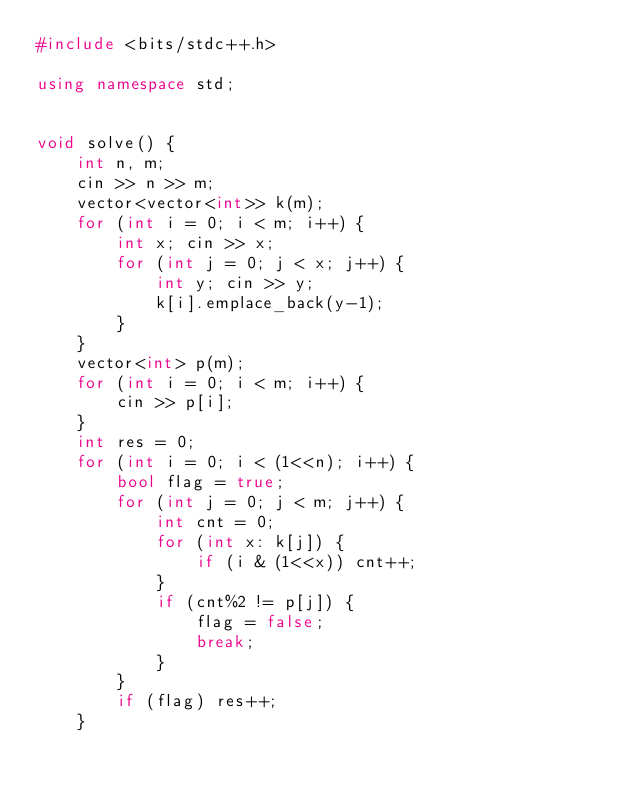<code> <loc_0><loc_0><loc_500><loc_500><_C++_>#include <bits/stdc++.h>

using namespace std;


void solve() {
    int n, m;
    cin >> n >> m;
    vector<vector<int>> k(m);
    for (int i = 0; i < m; i++) {
        int x; cin >> x;
        for (int j = 0; j < x; j++) {
            int y; cin >> y;
            k[i].emplace_back(y-1);
        }
    }
    vector<int> p(m);
    for (int i = 0; i < m; i++) {
        cin >> p[i];
    }
    int res = 0;
    for (int i = 0; i < (1<<n); i++) {
        bool flag = true;
        for (int j = 0; j < m; j++) {
            int cnt = 0;
            for (int x: k[j]) {
                if (i & (1<<x)) cnt++;
            }
            if (cnt%2 != p[j]) {
                flag = false;
                break;
            }
        }
        if (flag) res++;
    }</code> 